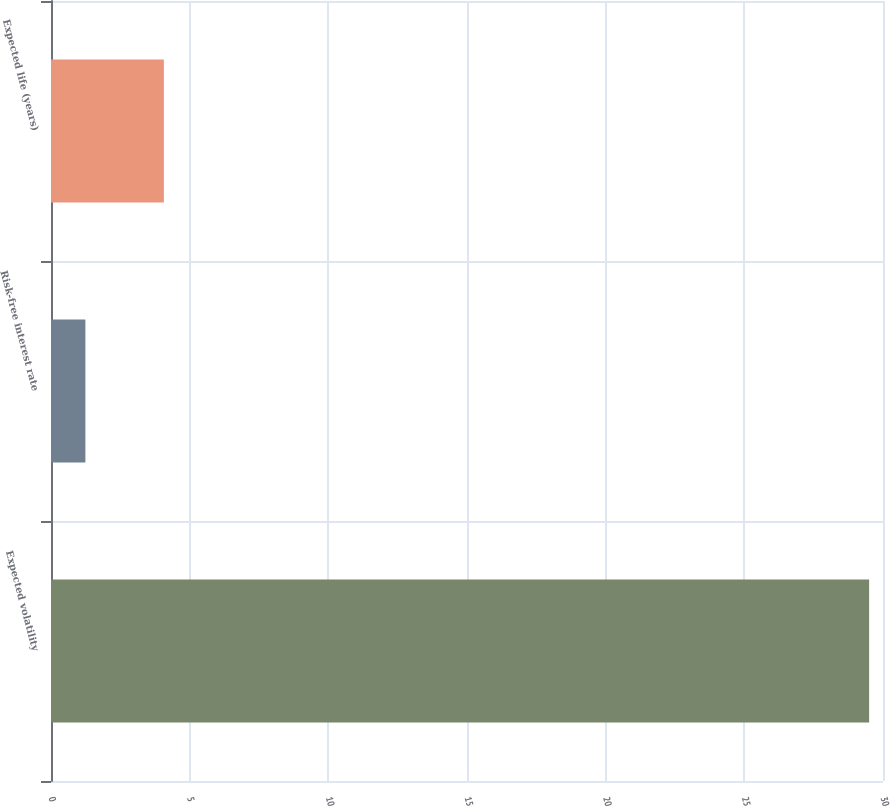Convert chart. <chart><loc_0><loc_0><loc_500><loc_500><bar_chart><fcel>Expected volatility<fcel>Risk-free interest rate<fcel>Expected life (years)<nl><fcel>29.5<fcel>1.24<fcel>4.07<nl></chart> 